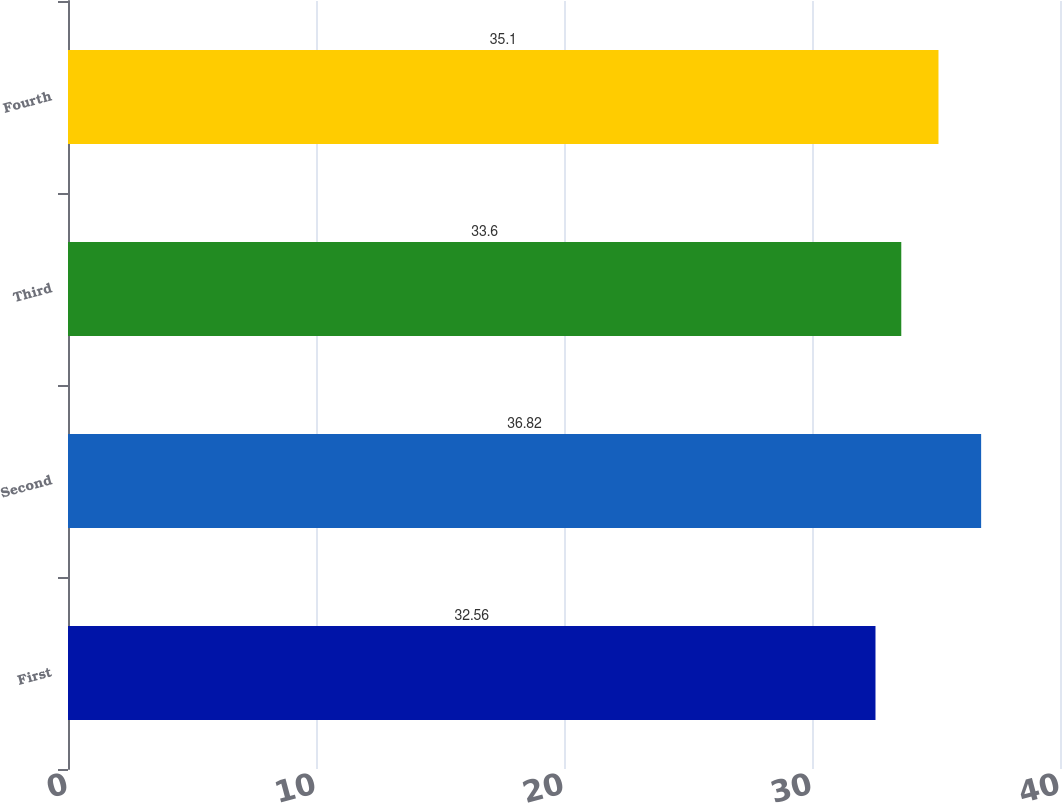<chart> <loc_0><loc_0><loc_500><loc_500><bar_chart><fcel>First<fcel>Second<fcel>Third<fcel>Fourth<nl><fcel>32.56<fcel>36.82<fcel>33.6<fcel>35.1<nl></chart> 